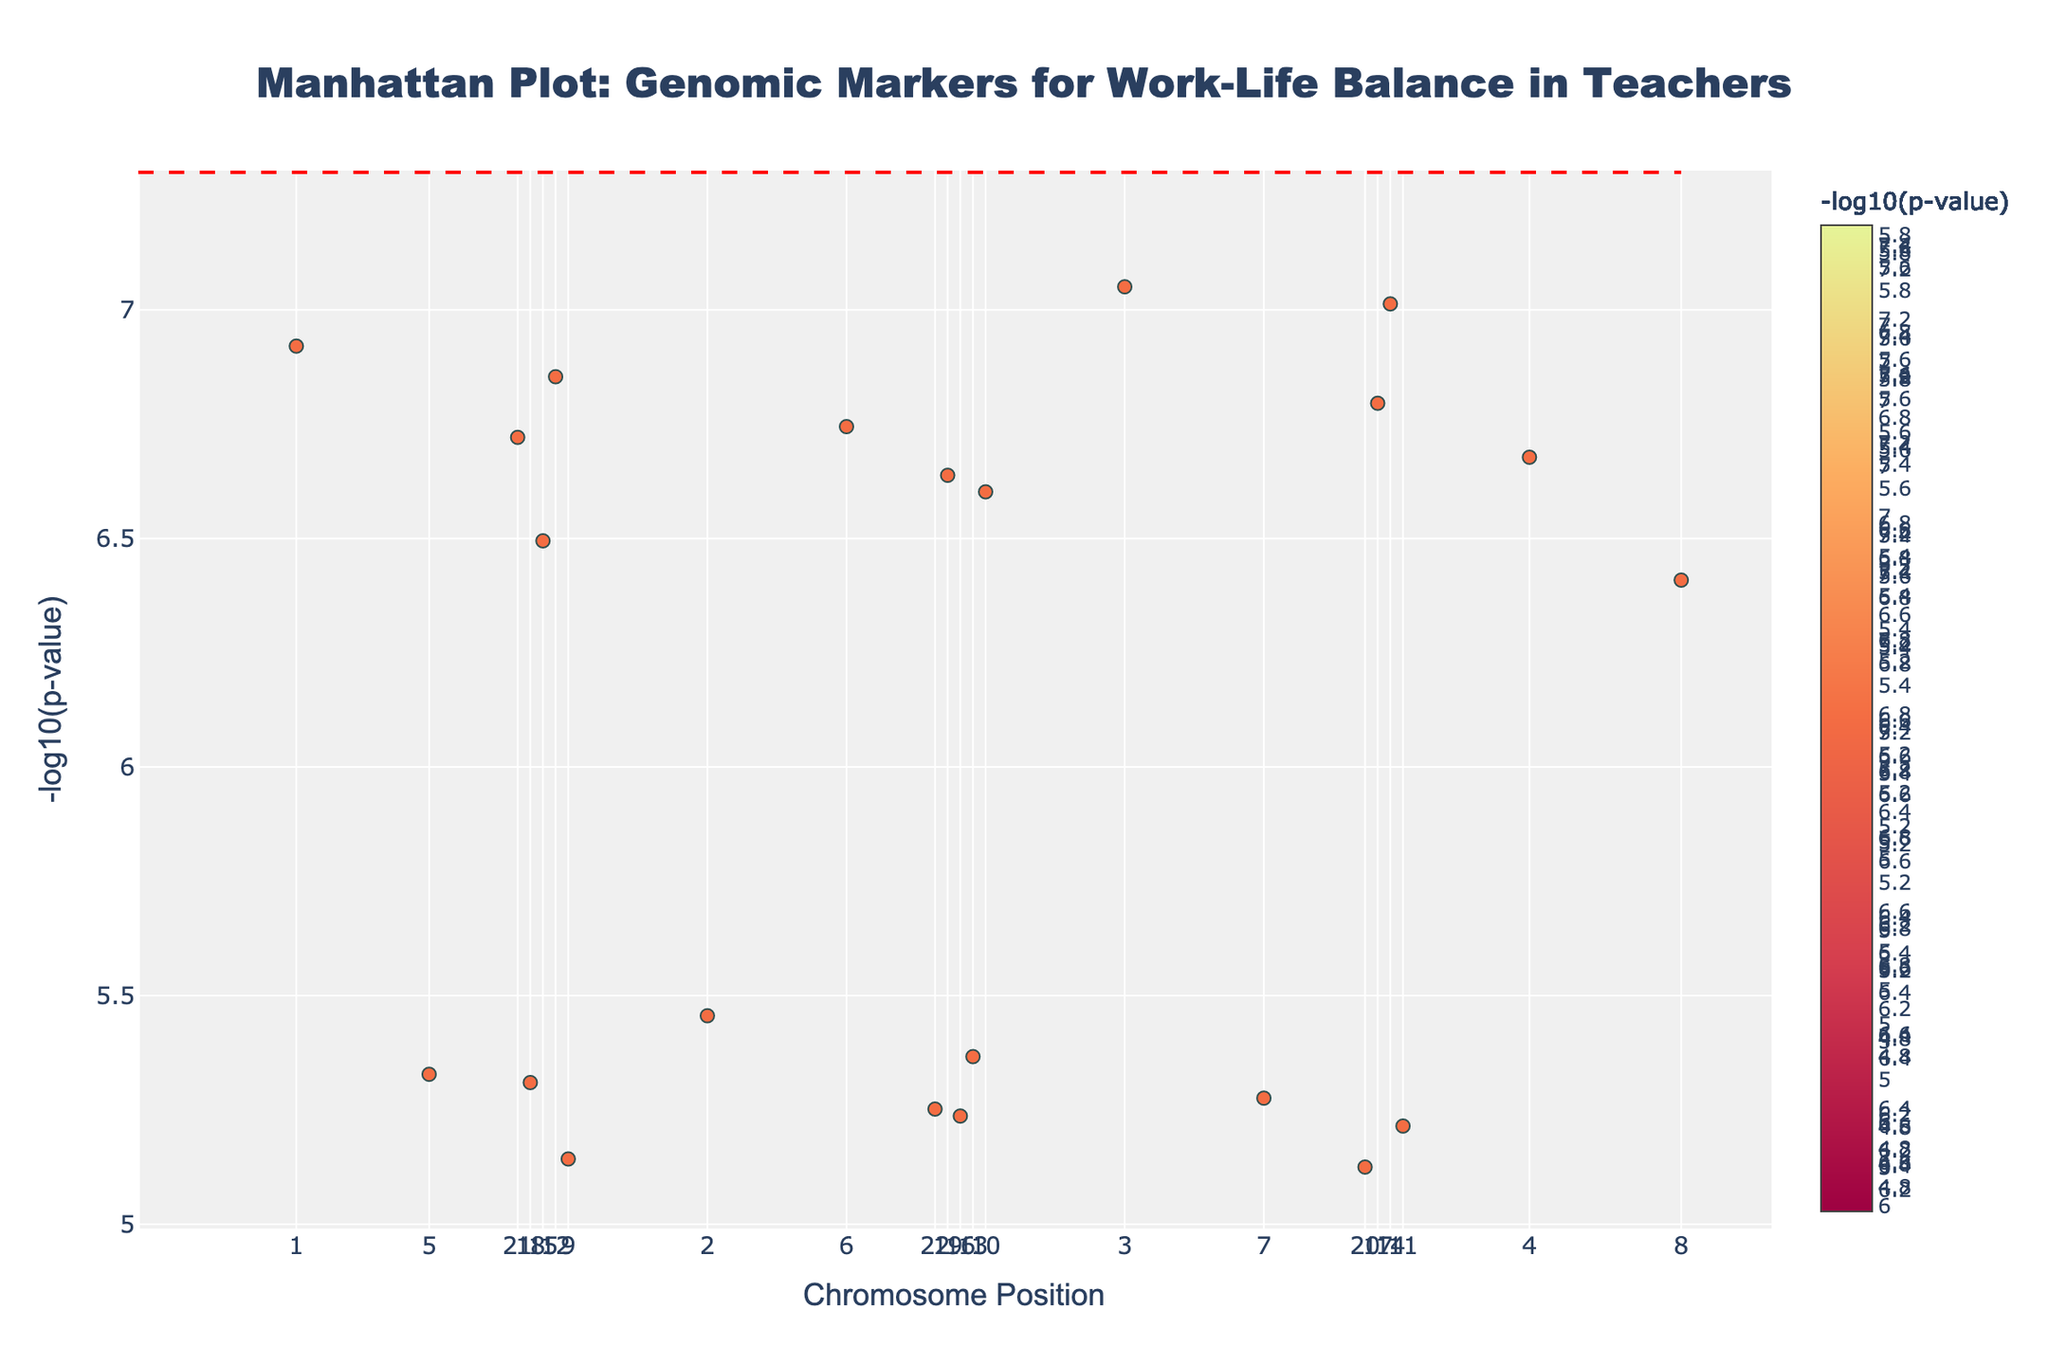What is the title of the plot? The title is displayed prominently at the top of the plot.
Answer: Manhattan Plot: Genomic Markers for Work-Life Balance in Teachers What do the colors on the plot represent? The colors correspond to the -log10(p-value) of the genomic markers.
Answer: The -log10(p-value) Which gene has the smallest p-value? The smallest p-value corresponds to the highest point on the y-axis, which in this case is around 8.9 for gene NPAS2 on Chromosome 3.
Answer: NPAS2 How many chromosomes have markers above the significance line? Identify the number of distinct chromosomes where any marker's -log10(p-value) is above the dashed significance line, indicating a p-value < 5e-8.
Answer: 2 (Chromosomes 3 and 14) Which gene on Chromosome 1 has the highest -log10(p-value)? Locate Chromosome 1 data points and identify the highest -log10(p-value), which corresponds to the gene CLOCK.
Answer: CLOCK What is the significance threshold represented by the dashed line? The dashed line represents a commonly used genome-wide significance threshold of -log10(5e-8).
Answer: -log10(5e-8) Which chromosome has the most markers above the -log10(p-value) of 6? Identify the chromosome with the highest density of markers surpassing the -log10(p-value) of 6.
Answer: Chromosome 14 Are there any genes on Chromosome 20 with a -log10(p-value) greater than 7? Examine Chromosome 20 data points to see if any markers exceed -log10(p-value) of 7.
Answer: No Which chromosome has the lowest average position for its markers? Calculate the average position for markers on each chromosome and identify the smallest average.
Answer: Chromosome 21 Which two genes have the closest positions on Chromosome 22? Compare the positions of markers on Chromosome 22 and identify the two closest in proximity.
Answer: Not applicable (only one marker) 